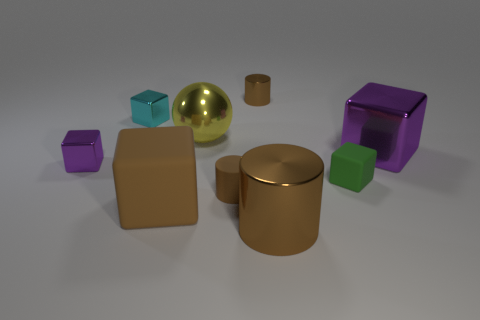What textures can be observed on the objects? The objects exhibit different textures. The cubes have a reflective, shiny surface, indicating a smooth and possibly metallic texture, while the cylindrical and spherical objects have a matte finish, suggesting a non-reflective, possibly rougher texture. Is there any pattern to the arrangement of the objects? There doesn't seem to be a specific pattern to the arrangement of the objects. They are scattered in a way that looks random, with no apparent order or sequence. 